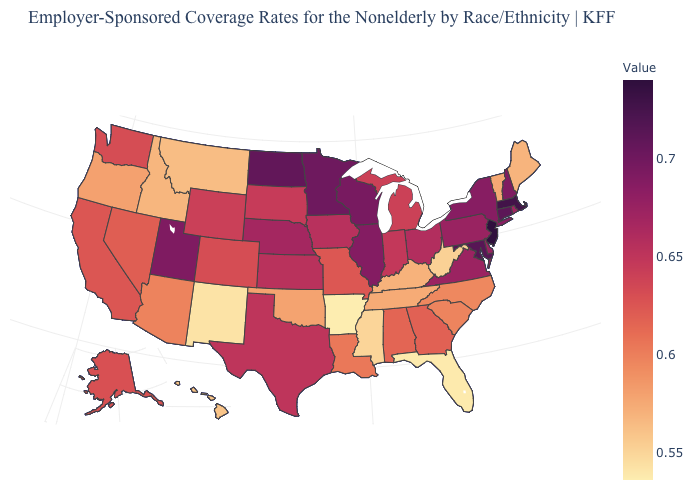Among the states that border Delaware , which have the highest value?
Quick response, please. New Jersey. Which states have the lowest value in the USA?
Concise answer only. Arkansas. Does Colorado have a lower value than South Carolina?
Concise answer only. No. Does Missouri have the lowest value in the MidWest?
Quick response, please. Yes. Does New Hampshire have the lowest value in the Northeast?
Short answer required. No. 